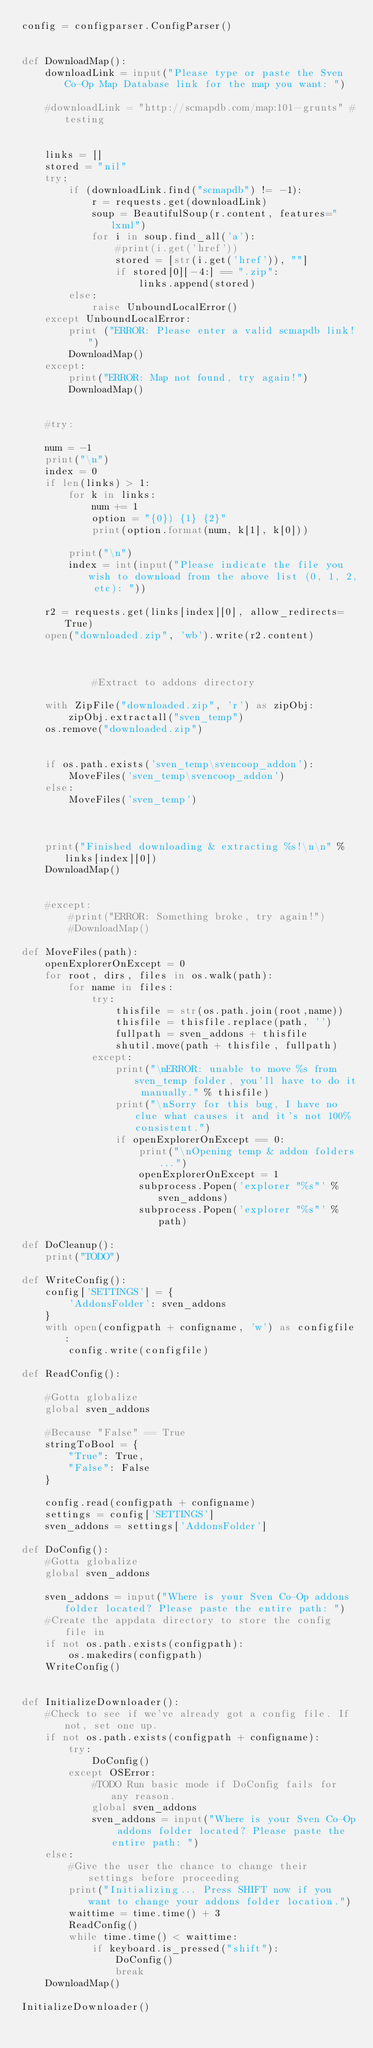<code> <loc_0><loc_0><loc_500><loc_500><_Python_>config = configparser.ConfigParser()


def DownloadMap():
    downloadLink = input("Please type or paste the Sven Co-Op Map Database link for the map you want: ")
    
    #downloadLink = "http://scmapdb.com/map:101-grunts" #testing


    links = []
    stored = "nil"
    try:
        if (downloadLink.find("scmapdb") != -1):
            r = requests.get(downloadLink)
            soup = BeautifulSoup(r.content, features="lxml")
            for i in soup.find_all('a'):
                #print(i.get('href'))
                stored = [str(i.get('href')), ""]
                if stored[0][-4:] == ".zip":
                    links.append(stored)
        else:
            raise UnboundLocalError()
    except UnboundLocalError:
        print ("ERROR: Please enter a valid scmapdb link!")
        DownloadMap()
    except:
        print("ERROR: Map not found, try again!")
        DownloadMap()
    
        
    #try:
        
    num = -1
    print("\n")
    index = 0
    if len(links) > 1:
        for k in links:
            num += 1
            option = "{0}) {1} {2}"
            print(option.format(num, k[1], k[0]))
                
        print("\n")
        index = int(input("Please indicate the file you wish to download from the above list (0, 1, 2, etc): "))
                
    r2 = requests.get(links[index][0], allow_redirects=True)
    open("downloaded.zip", 'wb').write(r2.content)
                
        
            
            #Extract to addons directory
            
    with ZipFile("downloaded.zip", 'r') as zipObj:
        zipObj.extractall("sven_temp")
    os.remove("downloaded.zip")
           
        
    if os.path.exists('sven_temp\svencoop_addon'):
        MoveFiles('sven_temp\svencoop_addon')
    else:
        MoveFiles('sven_temp')
            
    
            
    print("Finished downloading & extracting %s!\n\n" % links[index][0])
    DownloadMap()
        
        
    #except:
        #print("ERROR: Something broke, try again!")
        #DownloadMap()
        
def MoveFiles(path):
    openExplorerOnExcept = 0
    for root, dirs, files in os.walk(path):
        for name in files:
            try:
                thisfile = str(os.path.join(root,name))
                thisfile = thisfile.replace(path, '')
                fullpath = sven_addons + thisfile
                shutil.move(path + thisfile, fullpath)
            except:
                print("\nERROR: unable to move %s from sven_temp folder, you'll have to do it manually." % thisfile)
                print("\nSorry for this bug, I have no clue what causes it and it's not 100% consistent.")
                if openExplorerOnExcept == 0:
                    print("\nOpening temp & addon folders...")
                    openExplorerOnExcept = 1
                    subprocess.Popen('explorer "%s"' % sven_addons)
                    subprocess.Popen('explorer "%s"' % path)
   
def DoCleanup():
    print("TODO")
    
def WriteConfig():
    config['SETTINGS'] = {
        'AddonsFolder': sven_addons
    }
    with open(configpath + configname, 'w') as configfile:
        config.write(configfile)
    
def ReadConfig():
    
    #Gotta globalize
    global sven_addons
    
    #Because "False" == True
    stringToBool = {
        "True": True,
        "False": False
    }
    
    config.read(configpath + configname)
    settings = config['SETTINGS']
    sven_addons = settings['AddonsFolder']
    
def DoConfig():
    #Gotta globalize
    global sven_addons

    sven_addons = input("Where is your Sven Co-Op addons folder located? Please paste the entire path: ")
    #Create the appdata directory to store the config file in
    if not os.path.exists(configpath):
        os.makedirs(configpath)
    WriteConfig()


def InitializeDownloader():
    #Check to see if we've already got a config file. If not, set one up.
    if not os.path.exists(configpath + configname):
        try:
            DoConfig()
        except OSError:
            #TODO Run basic mode if DoConfig fails for any reason.
            global sven_addons
            sven_addons = input("Where is your Sven Co-Op addons folder located? Please paste the entire path: ")
    else:
        #Give the user the chance to change their settings before proceeding
        print("Initializing... Press SHIFT now if you want to change your addons folder location.")
        waittime = time.time() + 3
        ReadConfig()
        while time.time() < waittime:
            if keyboard.is_pressed("shift"):
                DoConfig()
                break
    DownloadMap()
    
InitializeDownloader()</code> 